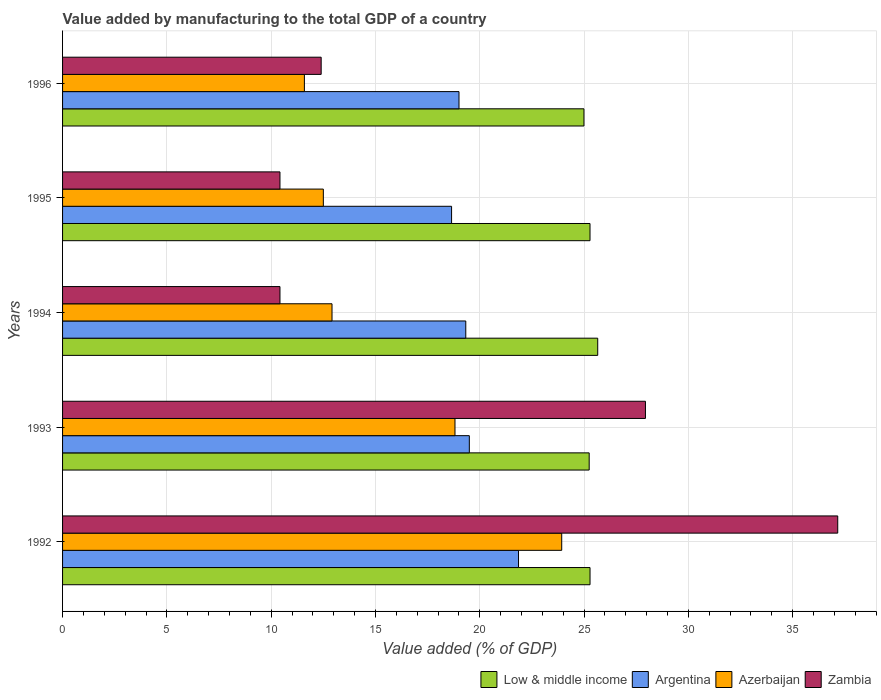How many bars are there on the 5th tick from the top?
Give a very brief answer. 4. How many bars are there on the 4th tick from the bottom?
Your answer should be compact. 4. What is the label of the 5th group of bars from the top?
Ensure brevity in your answer.  1992. In how many cases, is the number of bars for a given year not equal to the number of legend labels?
Give a very brief answer. 0. What is the value added by manufacturing to the total GDP in Azerbaijan in 1995?
Your response must be concise. 12.5. Across all years, what is the maximum value added by manufacturing to the total GDP in Argentina?
Provide a succinct answer. 21.86. Across all years, what is the minimum value added by manufacturing to the total GDP in Argentina?
Ensure brevity in your answer.  18.65. In which year was the value added by manufacturing to the total GDP in Low & middle income minimum?
Your answer should be compact. 1996. What is the total value added by manufacturing to the total GDP in Low & middle income in the graph?
Make the answer very short. 126.47. What is the difference between the value added by manufacturing to the total GDP in Zambia in 1993 and that in 1995?
Provide a succinct answer. 17.52. What is the difference between the value added by manufacturing to the total GDP in Argentina in 1992 and the value added by manufacturing to the total GDP in Low & middle income in 1995?
Your answer should be compact. -3.43. What is the average value added by manufacturing to the total GDP in Argentina per year?
Give a very brief answer. 19.67. In the year 1992, what is the difference between the value added by manufacturing to the total GDP in Argentina and value added by manufacturing to the total GDP in Low & middle income?
Offer a terse response. -3.43. In how many years, is the value added by manufacturing to the total GDP in Argentina greater than 32 %?
Offer a very short reply. 0. What is the ratio of the value added by manufacturing to the total GDP in Low & middle income in 1994 to that in 1996?
Provide a succinct answer. 1.03. Is the difference between the value added by manufacturing to the total GDP in Argentina in 1992 and 1994 greater than the difference between the value added by manufacturing to the total GDP in Low & middle income in 1992 and 1994?
Ensure brevity in your answer.  Yes. What is the difference between the highest and the second highest value added by manufacturing to the total GDP in Argentina?
Offer a very short reply. 2.36. What is the difference between the highest and the lowest value added by manufacturing to the total GDP in Low & middle income?
Give a very brief answer. 0.66. In how many years, is the value added by manufacturing to the total GDP in Argentina greater than the average value added by manufacturing to the total GDP in Argentina taken over all years?
Keep it short and to the point. 1. Is the sum of the value added by manufacturing to the total GDP in Argentina in 1993 and 1994 greater than the maximum value added by manufacturing to the total GDP in Zambia across all years?
Provide a short and direct response. Yes. Is it the case that in every year, the sum of the value added by manufacturing to the total GDP in Argentina and value added by manufacturing to the total GDP in Azerbaijan is greater than the sum of value added by manufacturing to the total GDP in Zambia and value added by manufacturing to the total GDP in Low & middle income?
Offer a terse response. No. What does the 4th bar from the top in 1994 represents?
Keep it short and to the point. Low & middle income. What does the 3rd bar from the bottom in 1994 represents?
Ensure brevity in your answer.  Azerbaijan. Is it the case that in every year, the sum of the value added by manufacturing to the total GDP in Azerbaijan and value added by manufacturing to the total GDP in Argentina is greater than the value added by manufacturing to the total GDP in Zambia?
Give a very brief answer. Yes. How many bars are there?
Make the answer very short. 20. Are all the bars in the graph horizontal?
Your answer should be compact. Yes. What is the difference between two consecutive major ticks on the X-axis?
Your response must be concise. 5. Are the values on the major ticks of X-axis written in scientific E-notation?
Ensure brevity in your answer.  No. Does the graph contain any zero values?
Ensure brevity in your answer.  No. Where does the legend appear in the graph?
Keep it short and to the point. Bottom right. How many legend labels are there?
Offer a terse response. 4. How are the legend labels stacked?
Make the answer very short. Horizontal. What is the title of the graph?
Keep it short and to the point. Value added by manufacturing to the total GDP of a country. Does "Cuba" appear as one of the legend labels in the graph?
Your answer should be compact. No. What is the label or title of the X-axis?
Offer a terse response. Value added (% of GDP). What is the Value added (% of GDP) of Low & middle income in 1992?
Provide a succinct answer. 25.29. What is the Value added (% of GDP) of Argentina in 1992?
Your response must be concise. 21.86. What is the Value added (% of GDP) of Azerbaijan in 1992?
Keep it short and to the point. 23.93. What is the Value added (% of GDP) in Zambia in 1992?
Provide a succinct answer. 37.16. What is the Value added (% of GDP) of Low & middle income in 1993?
Offer a terse response. 25.25. What is the Value added (% of GDP) in Argentina in 1993?
Your answer should be very brief. 19.5. What is the Value added (% of GDP) in Azerbaijan in 1993?
Keep it short and to the point. 18.81. What is the Value added (% of GDP) of Zambia in 1993?
Provide a short and direct response. 27.94. What is the Value added (% of GDP) in Low & middle income in 1994?
Provide a short and direct response. 25.66. What is the Value added (% of GDP) in Argentina in 1994?
Keep it short and to the point. 19.33. What is the Value added (% of GDP) of Azerbaijan in 1994?
Keep it short and to the point. 12.92. What is the Value added (% of GDP) in Zambia in 1994?
Keep it short and to the point. 10.42. What is the Value added (% of GDP) in Low & middle income in 1995?
Your response must be concise. 25.29. What is the Value added (% of GDP) of Argentina in 1995?
Your answer should be very brief. 18.65. What is the Value added (% of GDP) of Azerbaijan in 1995?
Your response must be concise. 12.5. What is the Value added (% of GDP) in Zambia in 1995?
Ensure brevity in your answer.  10.42. What is the Value added (% of GDP) of Low & middle income in 1996?
Your answer should be very brief. 25. What is the Value added (% of GDP) of Argentina in 1996?
Ensure brevity in your answer.  19.01. What is the Value added (% of GDP) of Azerbaijan in 1996?
Give a very brief answer. 11.59. What is the Value added (% of GDP) in Zambia in 1996?
Offer a very short reply. 12.4. Across all years, what is the maximum Value added (% of GDP) of Low & middle income?
Ensure brevity in your answer.  25.66. Across all years, what is the maximum Value added (% of GDP) in Argentina?
Provide a succinct answer. 21.86. Across all years, what is the maximum Value added (% of GDP) of Azerbaijan?
Offer a terse response. 23.93. Across all years, what is the maximum Value added (% of GDP) of Zambia?
Offer a terse response. 37.16. Across all years, what is the minimum Value added (% of GDP) of Low & middle income?
Give a very brief answer. 25. Across all years, what is the minimum Value added (% of GDP) in Argentina?
Make the answer very short. 18.65. Across all years, what is the minimum Value added (% of GDP) of Azerbaijan?
Provide a short and direct response. 11.59. Across all years, what is the minimum Value added (% of GDP) in Zambia?
Your answer should be compact. 10.42. What is the total Value added (% of GDP) of Low & middle income in the graph?
Offer a very short reply. 126.47. What is the total Value added (% of GDP) in Argentina in the graph?
Ensure brevity in your answer.  98.35. What is the total Value added (% of GDP) of Azerbaijan in the graph?
Offer a very short reply. 79.76. What is the total Value added (% of GDP) of Zambia in the graph?
Offer a very short reply. 98.35. What is the difference between the Value added (% of GDP) of Low & middle income in 1992 and that in 1993?
Your answer should be compact. 0.04. What is the difference between the Value added (% of GDP) of Argentina in 1992 and that in 1993?
Provide a short and direct response. 2.36. What is the difference between the Value added (% of GDP) of Azerbaijan in 1992 and that in 1993?
Provide a succinct answer. 5.12. What is the difference between the Value added (% of GDP) of Zambia in 1992 and that in 1993?
Provide a short and direct response. 9.22. What is the difference between the Value added (% of GDP) in Low & middle income in 1992 and that in 1994?
Your response must be concise. -0.37. What is the difference between the Value added (% of GDP) of Argentina in 1992 and that in 1994?
Provide a short and direct response. 2.53. What is the difference between the Value added (% of GDP) in Azerbaijan in 1992 and that in 1994?
Provide a succinct answer. 11.01. What is the difference between the Value added (% of GDP) of Zambia in 1992 and that in 1994?
Make the answer very short. 26.74. What is the difference between the Value added (% of GDP) of Low & middle income in 1992 and that in 1995?
Offer a very short reply. 0. What is the difference between the Value added (% of GDP) of Argentina in 1992 and that in 1995?
Your response must be concise. 3.21. What is the difference between the Value added (% of GDP) in Azerbaijan in 1992 and that in 1995?
Your response must be concise. 11.43. What is the difference between the Value added (% of GDP) of Zambia in 1992 and that in 1995?
Make the answer very short. 26.74. What is the difference between the Value added (% of GDP) in Low & middle income in 1992 and that in 1996?
Offer a terse response. 0.29. What is the difference between the Value added (% of GDP) of Argentina in 1992 and that in 1996?
Your answer should be very brief. 2.85. What is the difference between the Value added (% of GDP) in Azerbaijan in 1992 and that in 1996?
Provide a short and direct response. 12.34. What is the difference between the Value added (% of GDP) of Zambia in 1992 and that in 1996?
Provide a short and direct response. 24.77. What is the difference between the Value added (% of GDP) of Low & middle income in 1993 and that in 1994?
Make the answer very short. -0.41. What is the difference between the Value added (% of GDP) of Argentina in 1993 and that in 1994?
Ensure brevity in your answer.  0.17. What is the difference between the Value added (% of GDP) of Azerbaijan in 1993 and that in 1994?
Your answer should be very brief. 5.9. What is the difference between the Value added (% of GDP) of Zambia in 1993 and that in 1994?
Offer a terse response. 17.52. What is the difference between the Value added (% of GDP) of Low & middle income in 1993 and that in 1995?
Offer a terse response. -0.04. What is the difference between the Value added (% of GDP) in Argentina in 1993 and that in 1995?
Provide a short and direct response. 0.85. What is the difference between the Value added (% of GDP) in Azerbaijan in 1993 and that in 1995?
Provide a short and direct response. 6.31. What is the difference between the Value added (% of GDP) in Zambia in 1993 and that in 1995?
Provide a succinct answer. 17.52. What is the difference between the Value added (% of GDP) of Low & middle income in 1993 and that in 1996?
Your answer should be very brief. 0.25. What is the difference between the Value added (% of GDP) in Argentina in 1993 and that in 1996?
Offer a very short reply. 0.5. What is the difference between the Value added (% of GDP) of Azerbaijan in 1993 and that in 1996?
Your answer should be very brief. 7.22. What is the difference between the Value added (% of GDP) of Zambia in 1993 and that in 1996?
Give a very brief answer. 15.55. What is the difference between the Value added (% of GDP) of Low & middle income in 1994 and that in 1995?
Keep it short and to the point. 0.37. What is the difference between the Value added (% of GDP) in Argentina in 1994 and that in 1995?
Your answer should be very brief. 0.68. What is the difference between the Value added (% of GDP) in Azerbaijan in 1994 and that in 1995?
Provide a succinct answer. 0.42. What is the difference between the Value added (% of GDP) in Low & middle income in 1994 and that in 1996?
Provide a short and direct response. 0.66. What is the difference between the Value added (% of GDP) of Argentina in 1994 and that in 1996?
Offer a terse response. 0.33. What is the difference between the Value added (% of GDP) of Azerbaijan in 1994 and that in 1996?
Your response must be concise. 1.32. What is the difference between the Value added (% of GDP) of Zambia in 1994 and that in 1996?
Ensure brevity in your answer.  -1.98. What is the difference between the Value added (% of GDP) in Low & middle income in 1995 and that in 1996?
Keep it short and to the point. 0.29. What is the difference between the Value added (% of GDP) of Argentina in 1995 and that in 1996?
Your answer should be very brief. -0.36. What is the difference between the Value added (% of GDP) in Azerbaijan in 1995 and that in 1996?
Keep it short and to the point. 0.91. What is the difference between the Value added (% of GDP) in Zambia in 1995 and that in 1996?
Make the answer very short. -1.98. What is the difference between the Value added (% of GDP) of Low & middle income in 1992 and the Value added (% of GDP) of Argentina in 1993?
Provide a short and direct response. 5.79. What is the difference between the Value added (% of GDP) in Low & middle income in 1992 and the Value added (% of GDP) in Azerbaijan in 1993?
Give a very brief answer. 6.47. What is the difference between the Value added (% of GDP) of Low & middle income in 1992 and the Value added (% of GDP) of Zambia in 1993?
Provide a succinct answer. -2.66. What is the difference between the Value added (% of GDP) in Argentina in 1992 and the Value added (% of GDP) in Azerbaijan in 1993?
Make the answer very short. 3.05. What is the difference between the Value added (% of GDP) in Argentina in 1992 and the Value added (% of GDP) in Zambia in 1993?
Ensure brevity in your answer.  -6.09. What is the difference between the Value added (% of GDP) of Azerbaijan in 1992 and the Value added (% of GDP) of Zambia in 1993?
Make the answer very short. -4.01. What is the difference between the Value added (% of GDP) of Low & middle income in 1992 and the Value added (% of GDP) of Argentina in 1994?
Keep it short and to the point. 5.96. What is the difference between the Value added (% of GDP) of Low & middle income in 1992 and the Value added (% of GDP) of Azerbaijan in 1994?
Your answer should be very brief. 12.37. What is the difference between the Value added (% of GDP) of Low & middle income in 1992 and the Value added (% of GDP) of Zambia in 1994?
Ensure brevity in your answer.  14.87. What is the difference between the Value added (% of GDP) in Argentina in 1992 and the Value added (% of GDP) in Azerbaijan in 1994?
Keep it short and to the point. 8.94. What is the difference between the Value added (% of GDP) of Argentina in 1992 and the Value added (% of GDP) of Zambia in 1994?
Your response must be concise. 11.44. What is the difference between the Value added (% of GDP) of Azerbaijan in 1992 and the Value added (% of GDP) of Zambia in 1994?
Your response must be concise. 13.51. What is the difference between the Value added (% of GDP) in Low & middle income in 1992 and the Value added (% of GDP) in Argentina in 1995?
Ensure brevity in your answer.  6.64. What is the difference between the Value added (% of GDP) of Low & middle income in 1992 and the Value added (% of GDP) of Azerbaijan in 1995?
Give a very brief answer. 12.79. What is the difference between the Value added (% of GDP) of Low & middle income in 1992 and the Value added (% of GDP) of Zambia in 1995?
Offer a very short reply. 14.87. What is the difference between the Value added (% of GDP) in Argentina in 1992 and the Value added (% of GDP) in Azerbaijan in 1995?
Your response must be concise. 9.36. What is the difference between the Value added (% of GDP) in Argentina in 1992 and the Value added (% of GDP) in Zambia in 1995?
Ensure brevity in your answer.  11.44. What is the difference between the Value added (% of GDP) in Azerbaijan in 1992 and the Value added (% of GDP) in Zambia in 1995?
Keep it short and to the point. 13.51. What is the difference between the Value added (% of GDP) in Low & middle income in 1992 and the Value added (% of GDP) in Argentina in 1996?
Your answer should be compact. 6.28. What is the difference between the Value added (% of GDP) in Low & middle income in 1992 and the Value added (% of GDP) in Azerbaijan in 1996?
Keep it short and to the point. 13.69. What is the difference between the Value added (% of GDP) in Low & middle income in 1992 and the Value added (% of GDP) in Zambia in 1996?
Keep it short and to the point. 12.89. What is the difference between the Value added (% of GDP) of Argentina in 1992 and the Value added (% of GDP) of Azerbaijan in 1996?
Make the answer very short. 10.27. What is the difference between the Value added (% of GDP) of Argentina in 1992 and the Value added (% of GDP) of Zambia in 1996?
Your answer should be compact. 9.46. What is the difference between the Value added (% of GDP) of Azerbaijan in 1992 and the Value added (% of GDP) of Zambia in 1996?
Give a very brief answer. 11.53. What is the difference between the Value added (% of GDP) in Low & middle income in 1993 and the Value added (% of GDP) in Argentina in 1994?
Provide a succinct answer. 5.92. What is the difference between the Value added (% of GDP) of Low & middle income in 1993 and the Value added (% of GDP) of Azerbaijan in 1994?
Give a very brief answer. 12.33. What is the difference between the Value added (% of GDP) of Low & middle income in 1993 and the Value added (% of GDP) of Zambia in 1994?
Ensure brevity in your answer.  14.82. What is the difference between the Value added (% of GDP) in Argentina in 1993 and the Value added (% of GDP) in Azerbaijan in 1994?
Your response must be concise. 6.58. What is the difference between the Value added (% of GDP) in Argentina in 1993 and the Value added (% of GDP) in Zambia in 1994?
Offer a very short reply. 9.08. What is the difference between the Value added (% of GDP) in Azerbaijan in 1993 and the Value added (% of GDP) in Zambia in 1994?
Provide a short and direct response. 8.39. What is the difference between the Value added (% of GDP) in Low & middle income in 1993 and the Value added (% of GDP) in Argentina in 1995?
Ensure brevity in your answer.  6.6. What is the difference between the Value added (% of GDP) in Low & middle income in 1993 and the Value added (% of GDP) in Azerbaijan in 1995?
Your answer should be compact. 12.75. What is the difference between the Value added (% of GDP) in Low & middle income in 1993 and the Value added (% of GDP) in Zambia in 1995?
Ensure brevity in your answer.  14.83. What is the difference between the Value added (% of GDP) in Argentina in 1993 and the Value added (% of GDP) in Azerbaijan in 1995?
Offer a terse response. 7. What is the difference between the Value added (% of GDP) of Argentina in 1993 and the Value added (% of GDP) of Zambia in 1995?
Offer a terse response. 9.08. What is the difference between the Value added (% of GDP) in Azerbaijan in 1993 and the Value added (% of GDP) in Zambia in 1995?
Give a very brief answer. 8.39. What is the difference between the Value added (% of GDP) of Low & middle income in 1993 and the Value added (% of GDP) of Argentina in 1996?
Your answer should be very brief. 6.24. What is the difference between the Value added (% of GDP) of Low & middle income in 1993 and the Value added (% of GDP) of Azerbaijan in 1996?
Your answer should be very brief. 13.65. What is the difference between the Value added (% of GDP) in Low & middle income in 1993 and the Value added (% of GDP) in Zambia in 1996?
Make the answer very short. 12.85. What is the difference between the Value added (% of GDP) in Argentina in 1993 and the Value added (% of GDP) in Azerbaijan in 1996?
Keep it short and to the point. 7.91. What is the difference between the Value added (% of GDP) of Argentina in 1993 and the Value added (% of GDP) of Zambia in 1996?
Offer a terse response. 7.1. What is the difference between the Value added (% of GDP) of Azerbaijan in 1993 and the Value added (% of GDP) of Zambia in 1996?
Keep it short and to the point. 6.42. What is the difference between the Value added (% of GDP) in Low & middle income in 1994 and the Value added (% of GDP) in Argentina in 1995?
Ensure brevity in your answer.  7.01. What is the difference between the Value added (% of GDP) in Low & middle income in 1994 and the Value added (% of GDP) in Azerbaijan in 1995?
Your response must be concise. 13.15. What is the difference between the Value added (% of GDP) in Low & middle income in 1994 and the Value added (% of GDP) in Zambia in 1995?
Provide a succinct answer. 15.23. What is the difference between the Value added (% of GDP) in Argentina in 1994 and the Value added (% of GDP) in Azerbaijan in 1995?
Provide a succinct answer. 6.83. What is the difference between the Value added (% of GDP) of Argentina in 1994 and the Value added (% of GDP) of Zambia in 1995?
Your answer should be compact. 8.91. What is the difference between the Value added (% of GDP) in Azerbaijan in 1994 and the Value added (% of GDP) in Zambia in 1995?
Provide a succinct answer. 2.5. What is the difference between the Value added (% of GDP) of Low & middle income in 1994 and the Value added (% of GDP) of Argentina in 1996?
Offer a terse response. 6.65. What is the difference between the Value added (% of GDP) of Low & middle income in 1994 and the Value added (% of GDP) of Azerbaijan in 1996?
Make the answer very short. 14.06. What is the difference between the Value added (% of GDP) of Low & middle income in 1994 and the Value added (% of GDP) of Zambia in 1996?
Provide a succinct answer. 13.26. What is the difference between the Value added (% of GDP) of Argentina in 1994 and the Value added (% of GDP) of Azerbaijan in 1996?
Your response must be concise. 7.74. What is the difference between the Value added (% of GDP) in Argentina in 1994 and the Value added (% of GDP) in Zambia in 1996?
Your answer should be very brief. 6.93. What is the difference between the Value added (% of GDP) in Azerbaijan in 1994 and the Value added (% of GDP) in Zambia in 1996?
Your answer should be very brief. 0.52. What is the difference between the Value added (% of GDP) of Low & middle income in 1995 and the Value added (% of GDP) of Argentina in 1996?
Provide a short and direct response. 6.28. What is the difference between the Value added (% of GDP) of Low & middle income in 1995 and the Value added (% of GDP) of Azerbaijan in 1996?
Offer a terse response. 13.69. What is the difference between the Value added (% of GDP) of Low & middle income in 1995 and the Value added (% of GDP) of Zambia in 1996?
Your answer should be very brief. 12.89. What is the difference between the Value added (% of GDP) of Argentina in 1995 and the Value added (% of GDP) of Azerbaijan in 1996?
Provide a short and direct response. 7.06. What is the difference between the Value added (% of GDP) in Argentina in 1995 and the Value added (% of GDP) in Zambia in 1996?
Your answer should be compact. 6.25. What is the difference between the Value added (% of GDP) of Azerbaijan in 1995 and the Value added (% of GDP) of Zambia in 1996?
Provide a short and direct response. 0.1. What is the average Value added (% of GDP) of Low & middle income per year?
Provide a short and direct response. 25.3. What is the average Value added (% of GDP) in Argentina per year?
Make the answer very short. 19.67. What is the average Value added (% of GDP) of Azerbaijan per year?
Make the answer very short. 15.95. What is the average Value added (% of GDP) of Zambia per year?
Provide a short and direct response. 19.67. In the year 1992, what is the difference between the Value added (% of GDP) of Low & middle income and Value added (% of GDP) of Argentina?
Your answer should be very brief. 3.43. In the year 1992, what is the difference between the Value added (% of GDP) in Low & middle income and Value added (% of GDP) in Azerbaijan?
Provide a succinct answer. 1.36. In the year 1992, what is the difference between the Value added (% of GDP) of Low & middle income and Value added (% of GDP) of Zambia?
Offer a terse response. -11.88. In the year 1992, what is the difference between the Value added (% of GDP) of Argentina and Value added (% of GDP) of Azerbaijan?
Offer a terse response. -2.07. In the year 1992, what is the difference between the Value added (% of GDP) of Argentina and Value added (% of GDP) of Zambia?
Offer a very short reply. -15.3. In the year 1992, what is the difference between the Value added (% of GDP) of Azerbaijan and Value added (% of GDP) of Zambia?
Provide a short and direct response. -13.23. In the year 1993, what is the difference between the Value added (% of GDP) of Low & middle income and Value added (% of GDP) of Argentina?
Offer a terse response. 5.75. In the year 1993, what is the difference between the Value added (% of GDP) of Low & middle income and Value added (% of GDP) of Azerbaijan?
Offer a very short reply. 6.43. In the year 1993, what is the difference between the Value added (% of GDP) of Low & middle income and Value added (% of GDP) of Zambia?
Give a very brief answer. -2.7. In the year 1993, what is the difference between the Value added (% of GDP) of Argentina and Value added (% of GDP) of Azerbaijan?
Your response must be concise. 0.69. In the year 1993, what is the difference between the Value added (% of GDP) of Argentina and Value added (% of GDP) of Zambia?
Your response must be concise. -8.44. In the year 1993, what is the difference between the Value added (% of GDP) in Azerbaijan and Value added (% of GDP) in Zambia?
Your response must be concise. -9.13. In the year 1994, what is the difference between the Value added (% of GDP) of Low & middle income and Value added (% of GDP) of Argentina?
Give a very brief answer. 6.33. In the year 1994, what is the difference between the Value added (% of GDP) of Low & middle income and Value added (% of GDP) of Azerbaijan?
Provide a short and direct response. 12.74. In the year 1994, what is the difference between the Value added (% of GDP) in Low & middle income and Value added (% of GDP) in Zambia?
Provide a succinct answer. 15.23. In the year 1994, what is the difference between the Value added (% of GDP) in Argentina and Value added (% of GDP) in Azerbaijan?
Your answer should be compact. 6.41. In the year 1994, what is the difference between the Value added (% of GDP) of Argentina and Value added (% of GDP) of Zambia?
Keep it short and to the point. 8.91. In the year 1994, what is the difference between the Value added (% of GDP) in Azerbaijan and Value added (% of GDP) in Zambia?
Provide a succinct answer. 2.5. In the year 1995, what is the difference between the Value added (% of GDP) of Low & middle income and Value added (% of GDP) of Argentina?
Your answer should be very brief. 6.64. In the year 1995, what is the difference between the Value added (% of GDP) of Low & middle income and Value added (% of GDP) of Azerbaijan?
Offer a very short reply. 12.78. In the year 1995, what is the difference between the Value added (% of GDP) in Low & middle income and Value added (% of GDP) in Zambia?
Keep it short and to the point. 14.86. In the year 1995, what is the difference between the Value added (% of GDP) of Argentina and Value added (% of GDP) of Azerbaijan?
Give a very brief answer. 6.15. In the year 1995, what is the difference between the Value added (% of GDP) in Argentina and Value added (% of GDP) in Zambia?
Give a very brief answer. 8.23. In the year 1995, what is the difference between the Value added (% of GDP) in Azerbaijan and Value added (% of GDP) in Zambia?
Ensure brevity in your answer.  2.08. In the year 1996, what is the difference between the Value added (% of GDP) in Low & middle income and Value added (% of GDP) in Argentina?
Keep it short and to the point. 5.99. In the year 1996, what is the difference between the Value added (% of GDP) of Low & middle income and Value added (% of GDP) of Azerbaijan?
Offer a terse response. 13.4. In the year 1996, what is the difference between the Value added (% of GDP) of Low & middle income and Value added (% of GDP) of Zambia?
Your answer should be compact. 12.6. In the year 1996, what is the difference between the Value added (% of GDP) in Argentina and Value added (% of GDP) in Azerbaijan?
Keep it short and to the point. 7.41. In the year 1996, what is the difference between the Value added (% of GDP) in Argentina and Value added (% of GDP) in Zambia?
Offer a terse response. 6.61. In the year 1996, what is the difference between the Value added (% of GDP) in Azerbaijan and Value added (% of GDP) in Zambia?
Give a very brief answer. -0.8. What is the ratio of the Value added (% of GDP) of Low & middle income in 1992 to that in 1993?
Give a very brief answer. 1. What is the ratio of the Value added (% of GDP) in Argentina in 1992 to that in 1993?
Keep it short and to the point. 1.12. What is the ratio of the Value added (% of GDP) in Azerbaijan in 1992 to that in 1993?
Provide a succinct answer. 1.27. What is the ratio of the Value added (% of GDP) of Zambia in 1992 to that in 1993?
Make the answer very short. 1.33. What is the ratio of the Value added (% of GDP) of Low & middle income in 1992 to that in 1994?
Provide a succinct answer. 0.99. What is the ratio of the Value added (% of GDP) in Argentina in 1992 to that in 1994?
Your answer should be very brief. 1.13. What is the ratio of the Value added (% of GDP) in Azerbaijan in 1992 to that in 1994?
Your answer should be compact. 1.85. What is the ratio of the Value added (% of GDP) in Zambia in 1992 to that in 1994?
Your response must be concise. 3.57. What is the ratio of the Value added (% of GDP) of Low & middle income in 1992 to that in 1995?
Ensure brevity in your answer.  1. What is the ratio of the Value added (% of GDP) in Argentina in 1992 to that in 1995?
Your answer should be very brief. 1.17. What is the ratio of the Value added (% of GDP) in Azerbaijan in 1992 to that in 1995?
Offer a terse response. 1.91. What is the ratio of the Value added (% of GDP) of Zambia in 1992 to that in 1995?
Provide a succinct answer. 3.57. What is the ratio of the Value added (% of GDP) in Low & middle income in 1992 to that in 1996?
Give a very brief answer. 1.01. What is the ratio of the Value added (% of GDP) of Argentina in 1992 to that in 1996?
Provide a short and direct response. 1.15. What is the ratio of the Value added (% of GDP) of Azerbaijan in 1992 to that in 1996?
Offer a terse response. 2.06. What is the ratio of the Value added (% of GDP) in Zambia in 1992 to that in 1996?
Make the answer very short. 3. What is the ratio of the Value added (% of GDP) of Low & middle income in 1993 to that in 1994?
Your answer should be very brief. 0.98. What is the ratio of the Value added (% of GDP) of Argentina in 1993 to that in 1994?
Keep it short and to the point. 1.01. What is the ratio of the Value added (% of GDP) of Azerbaijan in 1993 to that in 1994?
Offer a very short reply. 1.46. What is the ratio of the Value added (% of GDP) of Zambia in 1993 to that in 1994?
Provide a succinct answer. 2.68. What is the ratio of the Value added (% of GDP) of Argentina in 1993 to that in 1995?
Keep it short and to the point. 1.05. What is the ratio of the Value added (% of GDP) in Azerbaijan in 1993 to that in 1995?
Provide a succinct answer. 1.5. What is the ratio of the Value added (% of GDP) in Zambia in 1993 to that in 1995?
Your response must be concise. 2.68. What is the ratio of the Value added (% of GDP) in Low & middle income in 1993 to that in 1996?
Your answer should be very brief. 1.01. What is the ratio of the Value added (% of GDP) in Argentina in 1993 to that in 1996?
Offer a very short reply. 1.03. What is the ratio of the Value added (% of GDP) in Azerbaijan in 1993 to that in 1996?
Ensure brevity in your answer.  1.62. What is the ratio of the Value added (% of GDP) of Zambia in 1993 to that in 1996?
Provide a short and direct response. 2.25. What is the ratio of the Value added (% of GDP) of Low & middle income in 1994 to that in 1995?
Make the answer very short. 1.01. What is the ratio of the Value added (% of GDP) in Argentina in 1994 to that in 1995?
Offer a terse response. 1.04. What is the ratio of the Value added (% of GDP) of Azerbaijan in 1994 to that in 1995?
Give a very brief answer. 1.03. What is the ratio of the Value added (% of GDP) in Zambia in 1994 to that in 1995?
Offer a very short reply. 1. What is the ratio of the Value added (% of GDP) of Low & middle income in 1994 to that in 1996?
Your response must be concise. 1.03. What is the ratio of the Value added (% of GDP) of Argentina in 1994 to that in 1996?
Ensure brevity in your answer.  1.02. What is the ratio of the Value added (% of GDP) in Azerbaijan in 1994 to that in 1996?
Provide a succinct answer. 1.11. What is the ratio of the Value added (% of GDP) in Zambia in 1994 to that in 1996?
Provide a short and direct response. 0.84. What is the ratio of the Value added (% of GDP) of Low & middle income in 1995 to that in 1996?
Offer a terse response. 1.01. What is the ratio of the Value added (% of GDP) of Argentina in 1995 to that in 1996?
Provide a succinct answer. 0.98. What is the ratio of the Value added (% of GDP) of Azerbaijan in 1995 to that in 1996?
Offer a very short reply. 1.08. What is the ratio of the Value added (% of GDP) in Zambia in 1995 to that in 1996?
Ensure brevity in your answer.  0.84. What is the difference between the highest and the second highest Value added (% of GDP) in Low & middle income?
Your response must be concise. 0.37. What is the difference between the highest and the second highest Value added (% of GDP) of Argentina?
Your answer should be compact. 2.36. What is the difference between the highest and the second highest Value added (% of GDP) of Azerbaijan?
Make the answer very short. 5.12. What is the difference between the highest and the second highest Value added (% of GDP) of Zambia?
Your answer should be compact. 9.22. What is the difference between the highest and the lowest Value added (% of GDP) in Low & middle income?
Ensure brevity in your answer.  0.66. What is the difference between the highest and the lowest Value added (% of GDP) in Argentina?
Offer a very short reply. 3.21. What is the difference between the highest and the lowest Value added (% of GDP) of Azerbaijan?
Provide a succinct answer. 12.34. What is the difference between the highest and the lowest Value added (% of GDP) in Zambia?
Ensure brevity in your answer.  26.74. 